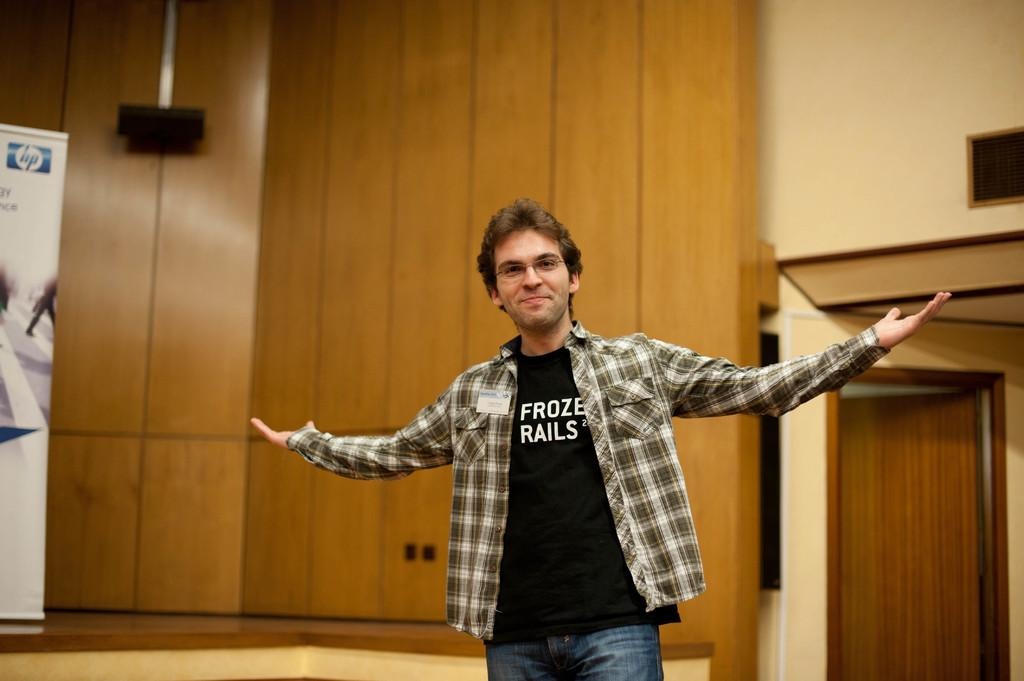What is the man in the image doing? The man is standing in the image and smiling. What can be seen in the background of the image? There is a door, a wall, an object, and a banner in the background of the image. Can you describe the object in the background? Unfortunately, the facts provided do not give a specific description of the object in the background. What type of hydrant is present in the image? There is no hydrant present in the image. Is the man in the image preparing to attack the door in the background? There is no indication in the image that the man is preparing to attack the door or any other object. 